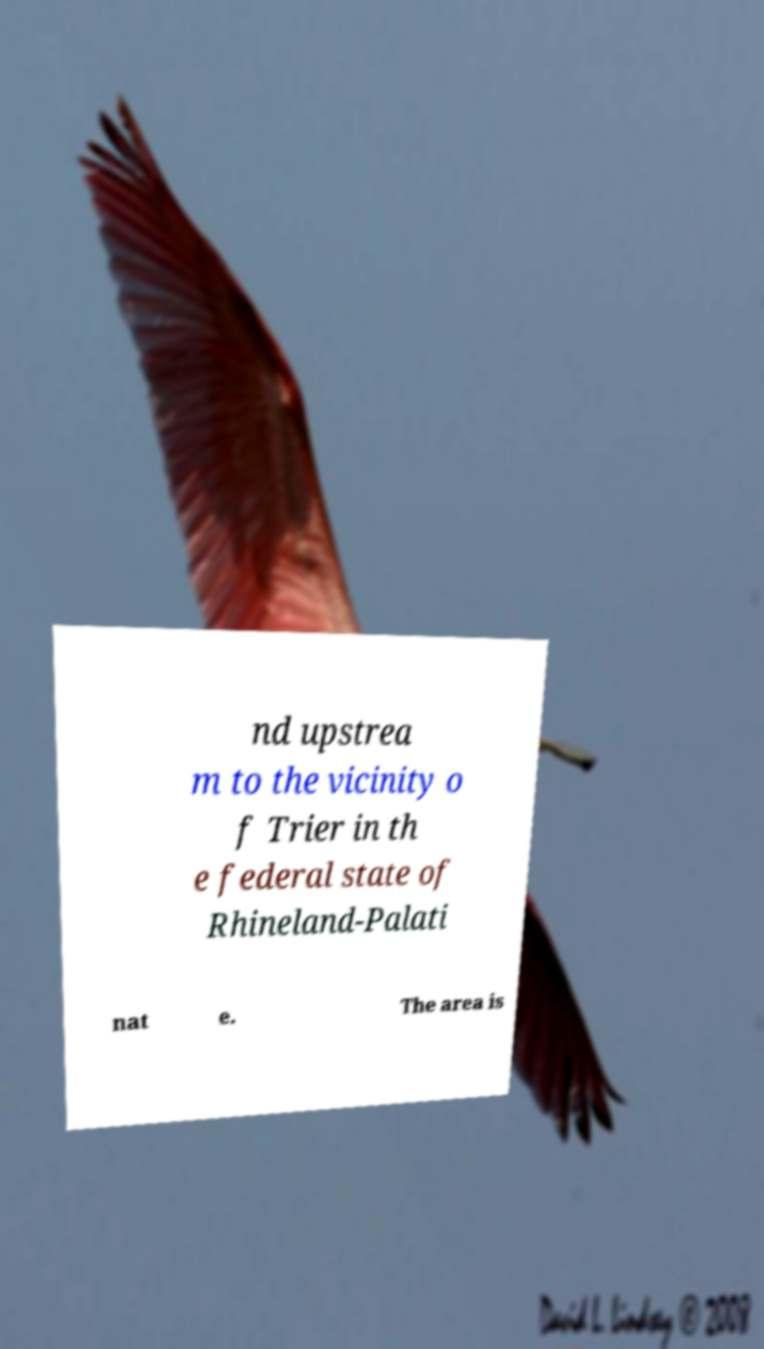Can you read and provide the text displayed in the image?This photo seems to have some interesting text. Can you extract and type it out for me? nd upstrea m to the vicinity o f Trier in th e federal state of Rhineland-Palati nat e. The area is 